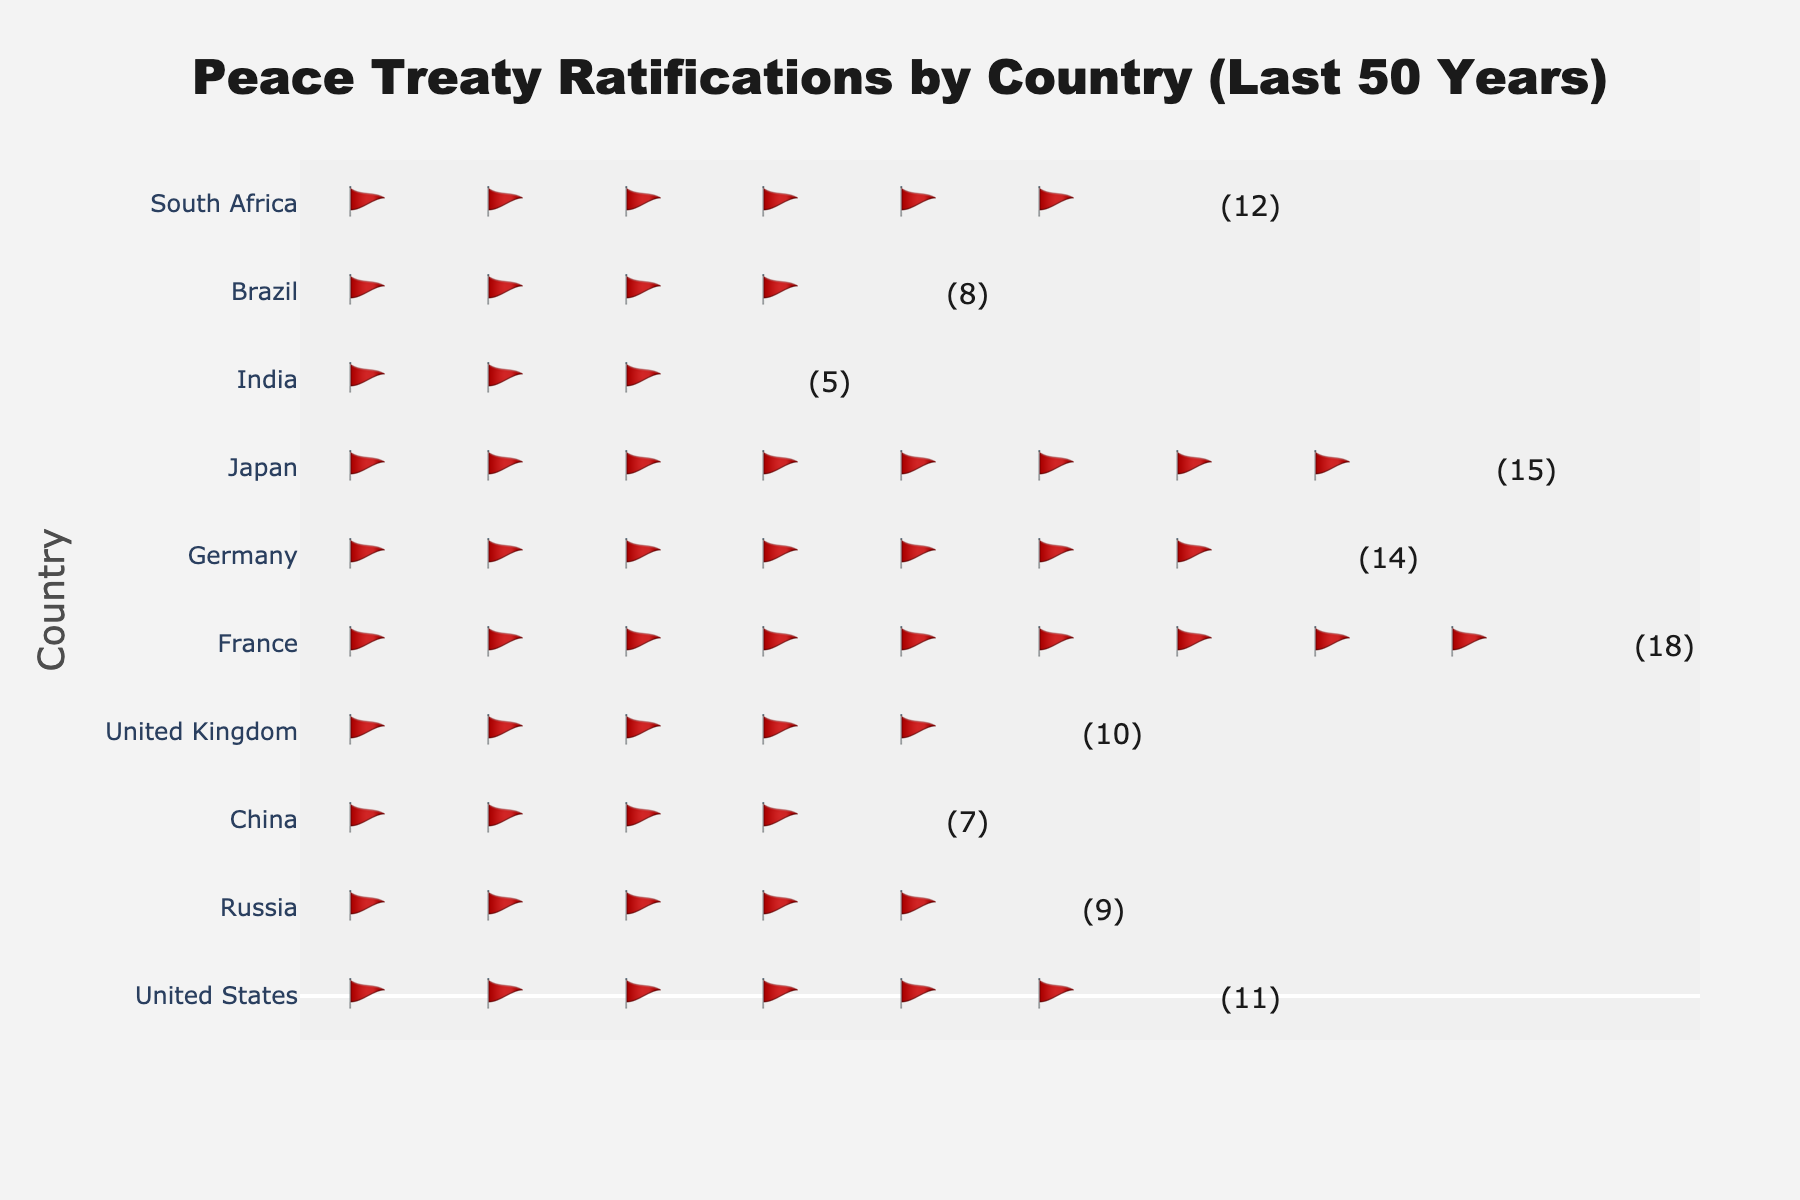what is the title of the figure? The title is positioned at the top center of the figure. It reads "Peace Treaty Ratifications by Country (Last 50 Years)" in a large font.
Answer: Peace Treaty Ratifications by Country (Last 50 Years) How many countries are compared in this figure? The y-axis of the figure lists the countries being compared. Count the number of tick labels on the y-axis.
Answer: 10 Which country has ratified the fewest peace treaties? Look at the number of flags next to each country's name on the y-axis. The country with the fewest flags has the least ratifications.
Answer: China Which country has the most peace treaties ratified? Look at the figure and identify which country has the highest number of flags depicted next to its name on the y-axis.
Answer: Germany How many peace treaties has Japan ratified? Next to Japan's name, locate the number of flags. Each flag represents 2 treaties. Count the flags and multiply by 2. Each flag count is labeled with the exact number of treaties in parentheses.
Answer: 10 Inspecting the figure, which country has ratified more peace treaties: the United Kingdom or Russia? Compare the number of flags next to "United Kingdom" and "Russia." The one with more flags has ratified more treaties.
Answer: United Kingdom What is the total number of peace treaties ratified by Germany and France combined? Find the number of peace treaties ratified by each country by adding the respective flags and multiplying by 2. Germany ratified 18 and France 14. Add these two numbers.
Answer: 32 By how many treaties did South Africa exceed the treaties ratified by China? Subtract the number of peace treaties ratified by China from those ratified by South Africa. Subtract 5 (China) from 11 (South Africa).
Answer: 6 Are there any countries with an equal number of peace treaties ratified? Compare the number of flags (and hence treaties) across all listed countries. Check if any two or more countries have the same number.
Answer: None have an equal number On average, how many peace treaties have been ratified per country? Sum the total number of peace treaties ratified by all the countries and divide by the number of countries. (12+8+5+15+14+18+10+7+9+11) / 10 = 109 / 10.
Answer: 10.9 